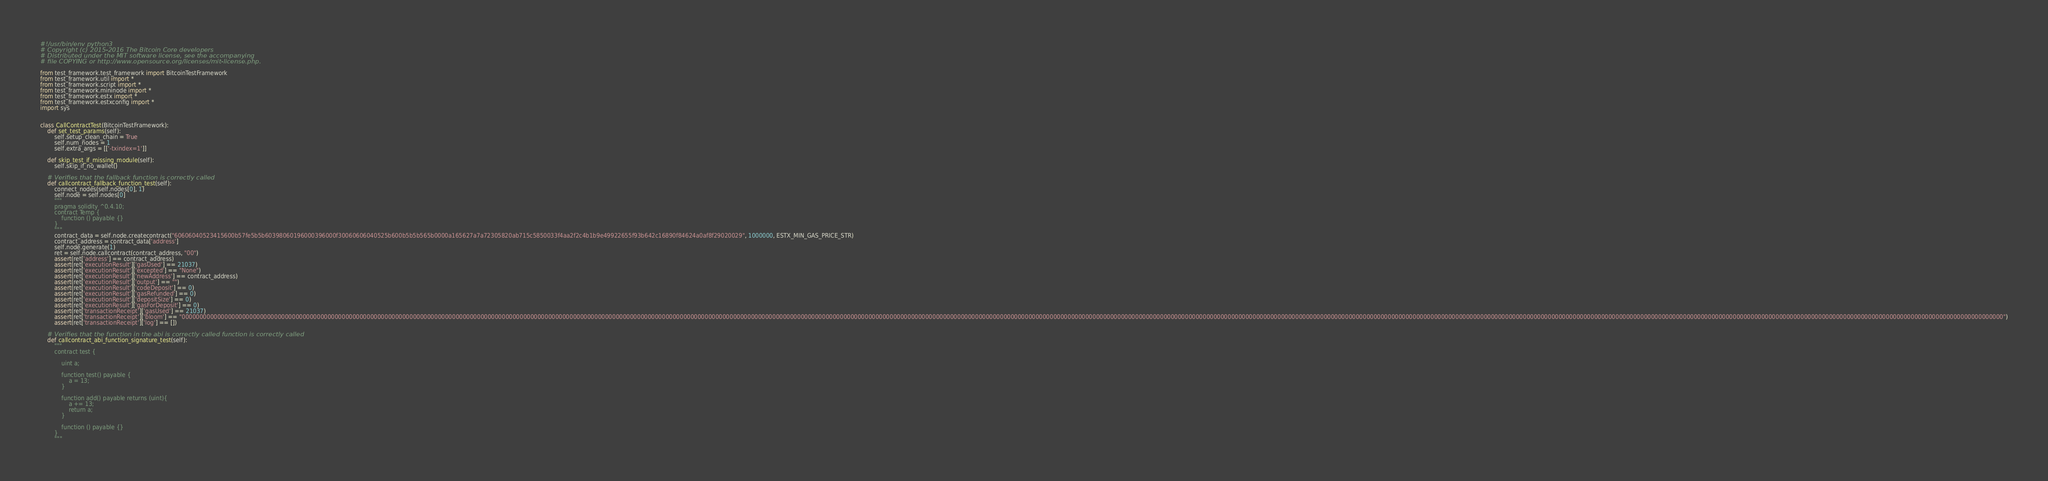Convert code to text. <code><loc_0><loc_0><loc_500><loc_500><_Python_>#!/usr/bin/env python3
# Copyright (c) 2015-2016 The Bitcoin Core developers
# Distributed under the MIT software license, see the accompanying
# file COPYING or http://www.opensource.org/licenses/mit-license.php.

from test_framework.test_framework import BitcoinTestFramework
from test_framework.util import *
from test_framework.script import *
from test_framework.mininode import *
from test_framework.estx import *
from test_framework.estxconfig import *
import sys


class CallContractTest(BitcoinTestFramework):
    def set_test_params(self):
        self.setup_clean_chain = True
        self.num_nodes = 1
        self.extra_args = [['-txindex=1']]

    def skip_test_if_missing_module(self):
        self.skip_if_no_wallet()

    # Verifies that the fallback function is correctly called
    def callcontract_fallback_function_test(self):
        connect_nodes(self.nodes[0], 1)
        self.node = self.nodes[0]
        """
        pragma solidity ^0.4.10;
        contract Temp {
            function () payable {}
        }
        """
        contract_data = self.node.createcontract("60606040523415600b57fe5b5b60398060196000396000f30060606040525b600b5b5b565b0000a165627a7a72305820ab715c5850033f4aa2f2c4b1b9e49922655f93b642c16890f84624a0af8f29020029", 1000000, ESTX_MIN_GAS_PRICE_STR)
        contract_address = contract_data['address']
        self.node.generate(1)
        ret = self.node.callcontract(contract_address, "00")
        assert(ret['address'] == contract_address)
        assert(ret['executionResult']['gasUsed'] == 21037)
        assert(ret['executionResult']['excepted'] == "None")
        assert(ret['executionResult']['newAddress'] == contract_address)
        assert(ret['executionResult']['output'] == "")
        assert(ret['executionResult']['codeDeposit'] == 0)
        assert(ret['executionResult']['gasRefunded'] == 0)
        assert(ret['executionResult']['depositSize'] == 0)
        assert(ret['executionResult']['gasForDeposit'] == 0)
        assert(ret['transactionReceipt']['gasUsed'] == 21037)
        assert(ret['transactionReceipt']['bloom'] == "00000000000000000000000000000000000000000000000000000000000000000000000000000000000000000000000000000000000000000000000000000000000000000000000000000000000000000000000000000000000000000000000000000000000000000000000000000000000000000000000000000000000000000000000000000000000000000000000000000000000000000000000000000000000000000000000000000000000000000000000000000000000000000000000000000000000000000000000000000000000000000000000000000000000000000000000000000000000000000000000000000000000000000000000000000000")
        assert(ret['transactionReceipt']['log'] == [])

    # Verifies that the function in the abi is correctly called function is correctly called
    def callcontract_abi_function_signature_test(self):
        """
        contract test {
            
            uint a;
            
            function test() payable {
                a = 13;
            }
            
            function add() payable returns (uint){
                a += 13;
                return a;
            }
            
            function () payable {}
        }
        """</code> 